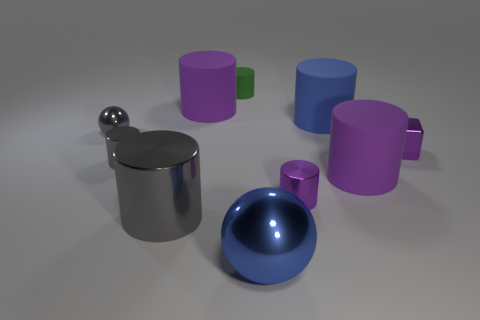What material is the sphere left of the purple matte cylinder on the left side of the green object that is behind the large shiny ball?
Give a very brief answer. Metal. Is the small green cylinder made of the same material as the tiny gray object that is in front of the gray ball?
Your response must be concise. No. Is the number of big purple objects that are behind the blue matte cylinder less than the number of large cylinders that are on the left side of the small gray metallic ball?
Make the answer very short. No. How many tiny purple objects are made of the same material as the small gray cylinder?
Your answer should be very brief. 2. There is a large purple cylinder that is on the left side of the big shiny object in front of the large gray shiny cylinder; is there a matte thing that is in front of it?
Keep it short and to the point. Yes. What number of blocks are either purple things or large rubber objects?
Keep it short and to the point. 1. Does the tiny green rubber object have the same shape as the purple thing to the left of the green rubber cylinder?
Provide a succinct answer. Yes. Are there fewer green rubber things to the left of the blue cylinder than tiny metal balls?
Offer a terse response. No. There is a small shiny sphere; are there any tiny cylinders to the left of it?
Offer a very short reply. No. Is there a purple matte object of the same shape as the blue matte thing?
Offer a very short reply. Yes. 